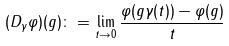<formula> <loc_0><loc_0><loc_500><loc_500>( D _ { \gamma } \varphi ) ( g ) \colon = \lim _ { t \to 0 } \frac { \varphi ( g \gamma ( t ) ) - \varphi ( g ) } { t }</formula> 